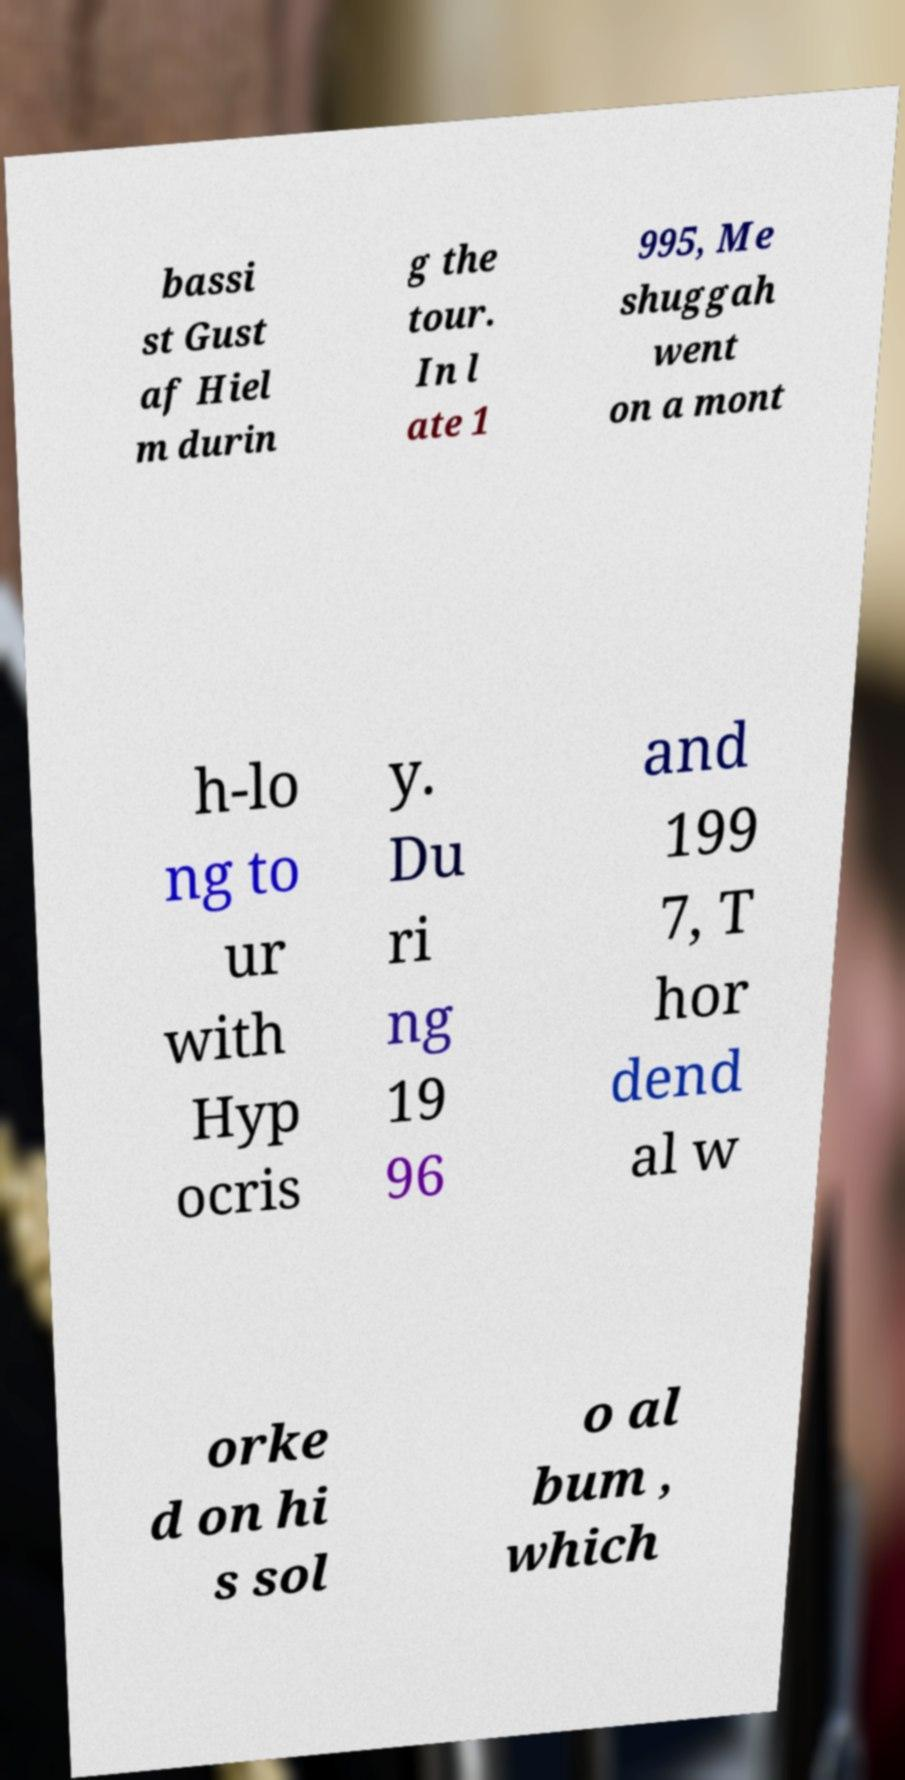Could you extract and type out the text from this image? bassi st Gust af Hiel m durin g the tour. In l ate 1 995, Me shuggah went on a mont h-lo ng to ur with Hyp ocris y. Du ri ng 19 96 and 199 7, T hor dend al w orke d on hi s sol o al bum , which 